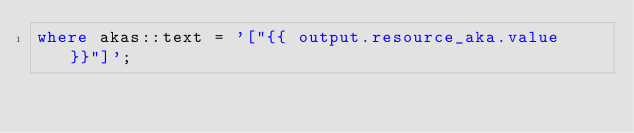Convert code to text. <code><loc_0><loc_0><loc_500><loc_500><_SQL_>where akas::text = '["{{ output.resource_aka.value }}"]';</code> 